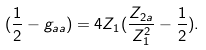Convert formula to latex. <formula><loc_0><loc_0><loc_500><loc_500>( \frac { 1 } { 2 } - g _ { a a } ) = 4 Z _ { 1 } ( \frac { Z _ { 2 a } } { Z ^ { 2 } _ { 1 } } - \frac { 1 } { 2 } ) .</formula> 